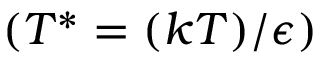Convert formula to latex. <formula><loc_0><loc_0><loc_500><loc_500>( T ^ { * } = ( k T ) / \epsilon )</formula> 